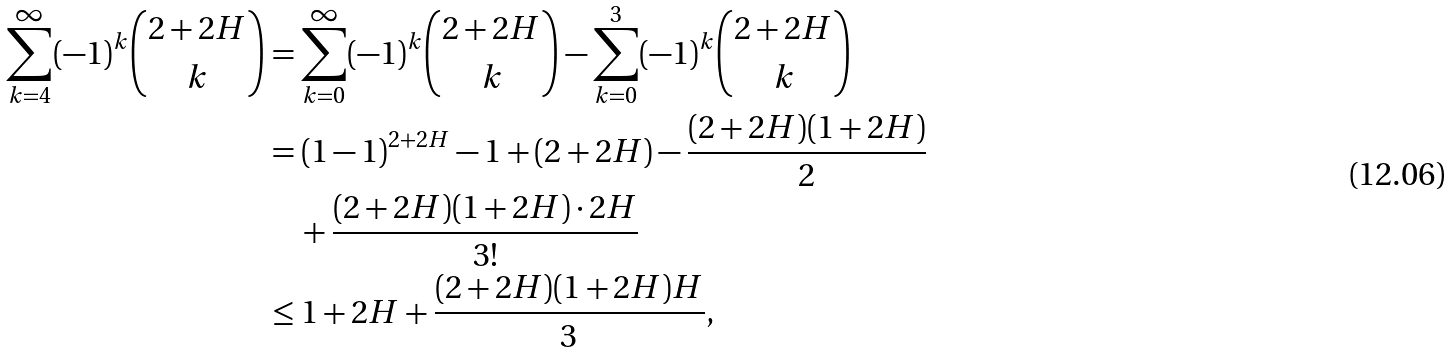Convert formula to latex. <formula><loc_0><loc_0><loc_500><loc_500>\sum _ { k = 4 } ^ { \infty } ( - 1 ) ^ { k } \binom { 2 + 2 H } { k } & = \sum _ { k = 0 } ^ { \infty } ( - 1 ) ^ { k } \binom { 2 + 2 H } { k } - \sum _ { k = 0 } ^ { 3 } ( - 1 ) ^ { k } \binom { 2 + 2 H } { k } \\ & = ( 1 - 1 ) ^ { 2 + 2 H } - 1 + ( 2 + 2 H ) - \frac { ( 2 + 2 H ) ( 1 + 2 H ) } { 2 } \\ & \quad + \frac { ( 2 + 2 H ) ( 1 + 2 H ) \cdot 2 H } { 3 ! } \\ & \leq 1 + 2 H + \frac { ( 2 + 2 H ) ( 1 + 2 H ) H } { 3 } ,</formula> 